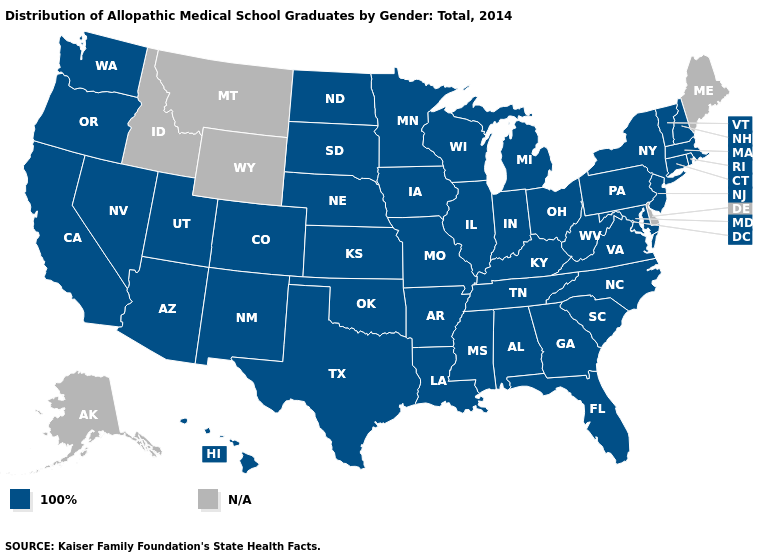Name the states that have a value in the range N/A?
Be succinct. Alaska, Delaware, Idaho, Maine, Montana, Wyoming. Is the legend a continuous bar?
Answer briefly. No. Which states have the lowest value in the South?
Short answer required. Alabama, Arkansas, Florida, Georgia, Kentucky, Louisiana, Maryland, Mississippi, North Carolina, Oklahoma, South Carolina, Tennessee, Texas, Virginia, West Virginia. What is the lowest value in the South?
Be succinct. 100%. Does the map have missing data?
Keep it brief. Yes. What is the value of New Mexico?
Quick response, please. 100%. Name the states that have a value in the range N/A?
Write a very short answer. Alaska, Delaware, Idaho, Maine, Montana, Wyoming. What is the value of North Dakota?
Quick response, please. 100%. What is the value of Ohio?
Short answer required. 100%. What is the highest value in the South ?
Short answer required. 100%. Does the map have missing data?
Be succinct. Yes. Which states have the highest value in the USA?
Give a very brief answer. Alabama, Arizona, Arkansas, California, Colorado, Connecticut, Florida, Georgia, Hawaii, Illinois, Indiana, Iowa, Kansas, Kentucky, Louisiana, Maryland, Massachusetts, Michigan, Minnesota, Mississippi, Missouri, Nebraska, Nevada, New Hampshire, New Jersey, New Mexico, New York, North Carolina, North Dakota, Ohio, Oklahoma, Oregon, Pennsylvania, Rhode Island, South Carolina, South Dakota, Tennessee, Texas, Utah, Vermont, Virginia, Washington, West Virginia, Wisconsin. Among the states that border New Hampshire , which have the lowest value?
Short answer required. Massachusetts, Vermont. What is the highest value in the USA?
Write a very short answer. 100%. 